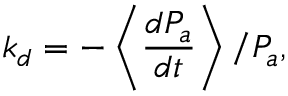<formula> <loc_0><loc_0><loc_500><loc_500>k _ { d } = - \left \langle \frac { d P _ { a } } { d t } \right \rangle / P _ { a } ,</formula> 